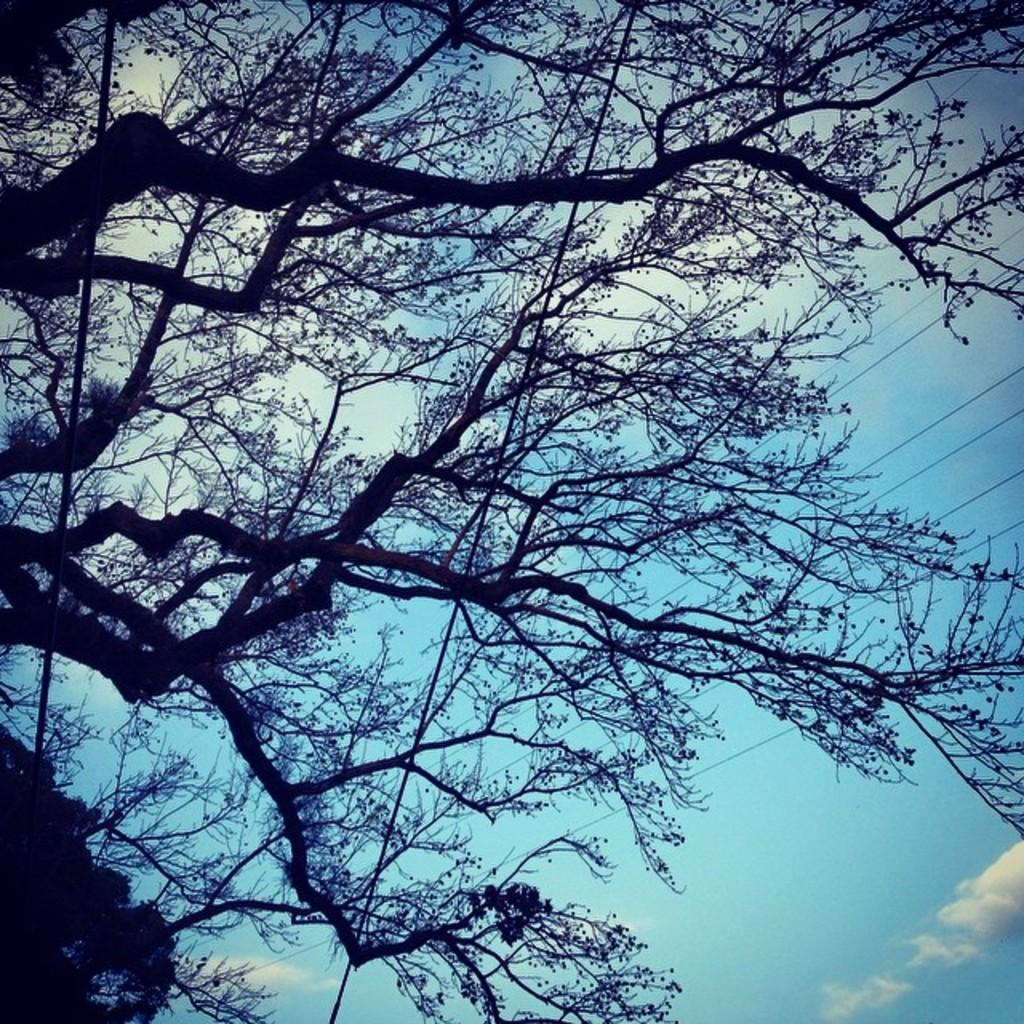How many wires can be seen in the image? There are three wires in the image. What can be seen in the background of the image? Clouds are present in the sky in the background of the image. What type of riddle is written on the plate in the image? There is no plate present in the image, and therefore no riddle can be observed. 